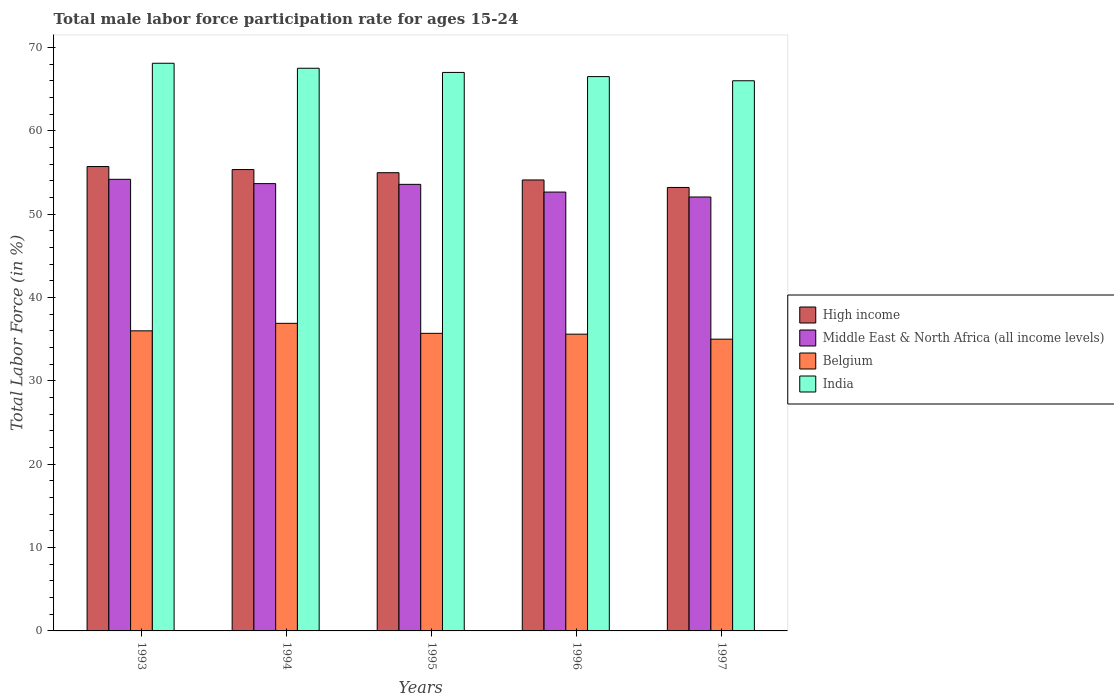How many different coloured bars are there?
Provide a succinct answer. 4. How many groups of bars are there?
Make the answer very short. 5. Are the number of bars per tick equal to the number of legend labels?
Offer a very short reply. Yes. How many bars are there on the 1st tick from the right?
Ensure brevity in your answer.  4. In how many cases, is the number of bars for a given year not equal to the number of legend labels?
Ensure brevity in your answer.  0. What is the male labor force participation rate in India in 1993?
Your answer should be compact. 68.1. Across all years, what is the maximum male labor force participation rate in India?
Keep it short and to the point. 68.1. Across all years, what is the minimum male labor force participation rate in High income?
Keep it short and to the point. 53.2. In which year was the male labor force participation rate in High income maximum?
Offer a very short reply. 1993. In which year was the male labor force participation rate in High income minimum?
Make the answer very short. 1997. What is the total male labor force participation rate in India in the graph?
Keep it short and to the point. 335.1. What is the difference between the male labor force participation rate in Middle East & North Africa (all income levels) in 1993 and that in 1996?
Give a very brief answer. 1.53. What is the difference between the male labor force participation rate in India in 1994 and the male labor force participation rate in Belgium in 1995?
Give a very brief answer. 31.8. What is the average male labor force participation rate in High income per year?
Keep it short and to the point. 54.67. In the year 1993, what is the difference between the male labor force participation rate in Belgium and male labor force participation rate in High income?
Your answer should be very brief. -19.71. What is the ratio of the male labor force participation rate in Middle East & North Africa (all income levels) in 1993 to that in 1995?
Ensure brevity in your answer.  1.01. Is the male labor force participation rate in High income in 1995 less than that in 1996?
Provide a short and direct response. No. Is the difference between the male labor force participation rate in Belgium in 1994 and 1996 greater than the difference between the male labor force participation rate in High income in 1994 and 1996?
Your answer should be very brief. Yes. What is the difference between the highest and the second highest male labor force participation rate in Belgium?
Keep it short and to the point. 0.9. What is the difference between the highest and the lowest male labor force participation rate in India?
Your answer should be very brief. 2.1. Is the sum of the male labor force participation rate in High income in 1994 and 1996 greater than the maximum male labor force participation rate in Middle East & North Africa (all income levels) across all years?
Keep it short and to the point. Yes. What does the 2nd bar from the left in 1995 represents?
Your answer should be very brief. Middle East & North Africa (all income levels). What does the 4th bar from the right in 1995 represents?
Ensure brevity in your answer.  High income. Is it the case that in every year, the sum of the male labor force participation rate in Middle East & North Africa (all income levels) and male labor force participation rate in India is greater than the male labor force participation rate in Belgium?
Make the answer very short. Yes. How many years are there in the graph?
Provide a short and direct response. 5. What is the difference between two consecutive major ticks on the Y-axis?
Your response must be concise. 10. Are the values on the major ticks of Y-axis written in scientific E-notation?
Ensure brevity in your answer.  No. Does the graph contain any zero values?
Give a very brief answer. No. Where does the legend appear in the graph?
Your answer should be very brief. Center right. How many legend labels are there?
Provide a succinct answer. 4. How are the legend labels stacked?
Your answer should be very brief. Vertical. What is the title of the graph?
Your answer should be compact. Total male labor force participation rate for ages 15-24. What is the label or title of the X-axis?
Your response must be concise. Years. What is the Total Labor Force (in %) of High income in 1993?
Offer a very short reply. 55.71. What is the Total Labor Force (in %) of Middle East & North Africa (all income levels) in 1993?
Your answer should be compact. 54.18. What is the Total Labor Force (in %) of India in 1993?
Provide a succinct answer. 68.1. What is the Total Labor Force (in %) in High income in 1994?
Your answer should be compact. 55.35. What is the Total Labor Force (in %) of Middle East & North Africa (all income levels) in 1994?
Make the answer very short. 53.66. What is the Total Labor Force (in %) in Belgium in 1994?
Make the answer very short. 36.9. What is the Total Labor Force (in %) of India in 1994?
Provide a short and direct response. 67.5. What is the Total Labor Force (in %) of High income in 1995?
Provide a succinct answer. 54.97. What is the Total Labor Force (in %) in Middle East & North Africa (all income levels) in 1995?
Keep it short and to the point. 53.57. What is the Total Labor Force (in %) of Belgium in 1995?
Provide a succinct answer. 35.7. What is the Total Labor Force (in %) of High income in 1996?
Keep it short and to the point. 54.1. What is the Total Labor Force (in %) in Middle East & North Africa (all income levels) in 1996?
Make the answer very short. 52.65. What is the Total Labor Force (in %) of Belgium in 1996?
Give a very brief answer. 35.6. What is the Total Labor Force (in %) of India in 1996?
Offer a very short reply. 66.5. What is the Total Labor Force (in %) of High income in 1997?
Make the answer very short. 53.2. What is the Total Labor Force (in %) in Middle East & North Africa (all income levels) in 1997?
Make the answer very short. 52.06. What is the Total Labor Force (in %) of Belgium in 1997?
Your answer should be compact. 35. What is the Total Labor Force (in %) of India in 1997?
Give a very brief answer. 66. Across all years, what is the maximum Total Labor Force (in %) of High income?
Offer a very short reply. 55.71. Across all years, what is the maximum Total Labor Force (in %) in Middle East & North Africa (all income levels)?
Ensure brevity in your answer.  54.18. Across all years, what is the maximum Total Labor Force (in %) of Belgium?
Give a very brief answer. 36.9. Across all years, what is the maximum Total Labor Force (in %) of India?
Ensure brevity in your answer.  68.1. Across all years, what is the minimum Total Labor Force (in %) of High income?
Your response must be concise. 53.2. Across all years, what is the minimum Total Labor Force (in %) of Middle East & North Africa (all income levels)?
Your answer should be very brief. 52.06. What is the total Total Labor Force (in %) in High income in the graph?
Keep it short and to the point. 273.33. What is the total Total Labor Force (in %) in Middle East & North Africa (all income levels) in the graph?
Give a very brief answer. 266.12. What is the total Total Labor Force (in %) of Belgium in the graph?
Your answer should be very brief. 179.2. What is the total Total Labor Force (in %) of India in the graph?
Offer a terse response. 335.1. What is the difference between the Total Labor Force (in %) in High income in 1993 and that in 1994?
Your response must be concise. 0.36. What is the difference between the Total Labor Force (in %) in Middle East & North Africa (all income levels) in 1993 and that in 1994?
Provide a short and direct response. 0.52. What is the difference between the Total Labor Force (in %) of Belgium in 1993 and that in 1994?
Keep it short and to the point. -0.9. What is the difference between the Total Labor Force (in %) of High income in 1993 and that in 1995?
Your answer should be very brief. 0.74. What is the difference between the Total Labor Force (in %) in Middle East & North Africa (all income levels) in 1993 and that in 1995?
Make the answer very short. 0.61. What is the difference between the Total Labor Force (in %) in Belgium in 1993 and that in 1995?
Your answer should be very brief. 0.3. What is the difference between the Total Labor Force (in %) in High income in 1993 and that in 1996?
Provide a short and direct response. 1.61. What is the difference between the Total Labor Force (in %) of Middle East & North Africa (all income levels) in 1993 and that in 1996?
Provide a short and direct response. 1.53. What is the difference between the Total Labor Force (in %) of High income in 1993 and that in 1997?
Your answer should be very brief. 2.51. What is the difference between the Total Labor Force (in %) of Middle East & North Africa (all income levels) in 1993 and that in 1997?
Keep it short and to the point. 2.12. What is the difference between the Total Labor Force (in %) in India in 1993 and that in 1997?
Provide a succinct answer. 2.1. What is the difference between the Total Labor Force (in %) in High income in 1994 and that in 1995?
Give a very brief answer. 0.38. What is the difference between the Total Labor Force (in %) of Middle East & North Africa (all income levels) in 1994 and that in 1995?
Your answer should be very brief. 0.09. What is the difference between the Total Labor Force (in %) of Belgium in 1994 and that in 1995?
Offer a terse response. 1.2. What is the difference between the Total Labor Force (in %) of India in 1994 and that in 1995?
Offer a very short reply. 0.5. What is the difference between the Total Labor Force (in %) in High income in 1994 and that in 1996?
Provide a succinct answer. 1.25. What is the difference between the Total Labor Force (in %) of Middle East & North Africa (all income levels) in 1994 and that in 1996?
Your answer should be very brief. 1.01. What is the difference between the Total Labor Force (in %) of Belgium in 1994 and that in 1996?
Offer a very short reply. 1.3. What is the difference between the Total Labor Force (in %) of India in 1994 and that in 1996?
Give a very brief answer. 1. What is the difference between the Total Labor Force (in %) of High income in 1994 and that in 1997?
Provide a short and direct response. 2.15. What is the difference between the Total Labor Force (in %) in Middle East & North Africa (all income levels) in 1994 and that in 1997?
Offer a terse response. 1.61. What is the difference between the Total Labor Force (in %) of Belgium in 1994 and that in 1997?
Offer a terse response. 1.9. What is the difference between the Total Labor Force (in %) of India in 1994 and that in 1997?
Offer a terse response. 1.5. What is the difference between the Total Labor Force (in %) in High income in 1995 and that in 1996?
Make the answer very short. 0.87. What is the difference between the Total Labor Force (in %) in Middle East & North Africa (all income levels) in 1995 and that in 1996?
Provide a short and direct response. 0.93. What is the difference between the Total Labor Force (in %) in India in 1995 and that in 1996?
Provide a succinct answer. 0.5. What is the difference between the Total Labor Force (in %) of High income in 1995 and that in 1997?
Provide a short and direct response. 1.77. What is the difference between the Total Labor Force (in %) in Middle East & North Africa (all income levels) in 1995 and that in 1997?
Give a very brief answer. 1.52. What is the difference between the Total Labor Force (in %) in Belgium in 1995 and that in 1997?
Offer a terse response. 0.7. What is the difference between the Total Labor Force (in %) in India in 1995 and that in 1997?
Ensure brevity in your answer.  1. What is the difference between the Total Labor Force (in %) in High income in 1996 and that in 1997?
Give a very brief answer. 0.9. What is the difference between the Total Labor Force (in %) in Middle East & North Africa (all income levels) in 1996 and that in 1997?
Provide a succinct answer. 0.59. What is the difference between the Total Labor Force (in %) in Belgium in 1996 and that in 1997?
Make the answer very short. 0.6. What is the difference between the Total Labor Force (in %) of High income in 1993 and the Total Labor Force (in %) of Middle East & North Africa (all income levels) in 1994?
Provide a short and direct response. 2.05. What is the difference between the Total Labor Force (in %) in High income in 1993 and the Total Labor Force (in %) in Belgium in 1994?
Your answer should be very brief. 18.81. What is the difference between the Total Labor Force (in %) of High income in 1993 and the Total Labor Force (in %) of India in 1994?
Your answer should be very brief. -11.79. What is the difference between the Total Labor Force (in %) of Middle East & North Africa (all income levels) in 1993 and the Total Labor Force (in %) of Belgium in 1994?
Keep it short and to the point. 17.28. What is the difference between the Total Labor Force (in %) in Middle East & North Africa (all income levels) in 1993 and the Total Labor Force (in %) in India in 1994?
Your response must be concise. -13.32. What is the difference between the Total Labor Force (in %) of Belgium in 1993 and the Total Labor Force (in %) of India in 1994?
Give a very brief answer. -31.5. What is the difference between the Total Labor Force (in %) in High income in 1993 and the Total Labor Force (in %) in Middle East & North Africa (all income levels) in 1995?
Your response must be concise. 2.14. What is the difference between the Total Labor Force (in %) of High income in 1993 and the Total Labor Force (in %) of Belgium in 1995?
Provide a short and direct response. 20.01. What is the difference between the Total Labor Force (in %) in High income in 1993 and the Total Labor Force (in %) in India in 1995?
Give a very brief answer. -11.29. What is the difference between the Total Labor Force (in %) of Middle East & North Africa (all income levels) in 1993 and the Total Labor Force (in %) of Belgium in 1995?
Provide a succinct answer. 18.48. What is the difference between the Total Labor Force (in %) of Middle East & North Africa (all income levels) in 1993 and the Total Labor Force (in %) of India in 1995?
Ensure brevity in your answer.  -12.82. What is the difference between the Total Labor Force (in %) in Belgium in 1993 and the Total Labor Force (in %) in India in 1995?
Provide a succinct answer. -31. What is the difference between the Total Labor Force (in %) of High income in 1993 and the Total Labor Force (in %) of Middle East & North Africa (all income levels) in 1996?
Provide a short and direct response. 3.06. What is the difference between the Total Labor Force (in %) in High income in 1993 and the Total Labor Force (in %) in Belgium in 1996?
Your response must be concise. 20.11. What is the difference between the Total Labor Force (in %) of High income in 1993 and the Total Labor Force (in %) of India in 1996?
Give a very brief answer. -10.79. What is the difference between the Total Labor Force (in %) in Middle East & North Africa (all income levels) in 1993 and the Total Labor Force (in %) in Belgium in 1996?
Make the answer very short. 18.58. What is the difference between the Total Labor Force (in %) of Middle East & North Africa (all income levels) in 1993 and the Total Labor Force (in %) of India in 1996?
Your answer should be compact. -12.32. What is the difference between the Total Labor Force (in %) of Belgium in 1993 and the Total Labor Force (in %) of India in 1996?
Your answer should be very brief. -30.5. What is the difference between the Total Labor Force (in %) of High income in 1993 and the Total Labor Force (in %) of Middle East & North Africa (all income levels) in 1997?
Your response must be concise. 3.65. What is the difference between the Total Labor Force (in %) in High income in 1993 and the Total Labor Force (in %) in Belgium in 1997?
Your answer should be very brief. 20.71. What is the difference between the Total Labor Force (in %) of High income in 1993 and the Total Labor Force (in %) of India in 1997?
Provide a succinct answer. -10.29. What is the difference between the Total Labor Force (in %) in Middle East & North Africa (all income levels) in 1993 and the Total Labor Force (in %) in Belgium in 1997?
Your answer should be very brief. 19.18. What is the difference between the Total Labor Force (in %) of Middle East & North Africa (all income levels) in 1993 and the Total Labor Force (in %) of India in 1997?
Give a very brief answer. -11.82. What is the difference between the Total Labor Force (in %) in Belgium in 1993 and the Total Labor Force (in %) in India in 1997?
Give a very brief answer. -30. What is the difference between the Total Labor Force (in %) in High income in 1994 and the Total Labor Force (in %) in Middle East & North Africa (all income levels) in 1995?
Provide a succinct answer. 1.78. What is the difference between the Total Labor Force (in %) of High income in 1994 and the Total Labor Force (in %) of Belgium in 1995?
Provide a short and direct response. 19.65. What is the difference between the Total Labor Force (in %) of High income in 1994 and the Total Labor Force (in %) of India in 1995?
Provide a succinct answer. -11.65. What is the difference between the Total Labor Force (in %) in Middle East & North Africa (all income levels) in 1994 and the Total Labor Force (in %) in Belgium in 1995?
Your answer should be compact. 17.96. What is the difference between the Total Labor Force (in %) of Middle East & North Africa (all income levels) in 1994 and the Total Labor Force (in %) of India in 1995?
Ensure brevity in your answer.  -13.34. What is the difference between the Total Labor Force (in %) of Belgium in 1994 and the Total Labor Force (in %) of India in 1995?
Give a very brief answer. -30.1. What is the difference between the Total Labor Force (in %) in High income in 1994 and the Total Labor Force (in %) in Middle East & North Africa (all income levels) in 1996?
Your answer should be compact. 2.7. What is the difference between the Total Labor Force (in %) of High income in 1994 and the Total Labor Force (in %) of Belgium in 1996?
Your answer should be compact. 19.75. What is the difference between the Total Labor Force (in %) in High income in 1994 and the Total Labor Force (in %) in India in 1996?
Your answer should be compact. -11.15. What is the difference between the Total Labor Force (in %) of Middle East & North Africa (all income levels) in 1994 and the Total Labor Force (in %) of Belgium in 1996?
Ensure brevity in your answer.  18.06. What is the difference between the Total Labor Force (in %) of Middle East & North Africa (all income levels) in 1994 and the Total Labor Force (in %) of India in 1996?
Make the answer very short. -12.84. What is the difference between the Total Labor Force (in %) of Belgium in 1994 and the Total Labor Force (in %) of India in 1996?
Your answer should be very brief. -29.6. What is the difference between the Total Labor Force (in %) of High income in 1994 and the Total Labor Force (in %) of Middle East & North Africa (all income levels) in 1997?
Provide a short and direct response. 3.29. What is the difference between the Total Labor Force (in %) in High income in 1994 and the Total Labor Force (in %) in Belgium in 1997?
Your response must be concise. 20.35. What is the difference between the Total Labor Force (in %) of High income in 1994 and the Total Labor Force (in %) of India in 1997?
Provide a succinct answer. -10.65. What is the difference between the Total Labor Force (in %) of Middle East & North Africa (all income levels) in 1994 and the Total Labor Force (in %) of Belgium in 1997?
Your answer should be very brief. 18.66. What is the difference between the Total Labor Force (in %) of Middle East & North Africa (all income levels) in 1994 and the Total Labor Force (in %) of India in 1997?
Offer a terse response. -12.34. What is the difference between the Total Labor Force (in %) in Belgium in 1994 and the Total Labor Force (in %) in India in 1997?
Provide a short and direct response. -29.1. What is the difference between the Total Labor Force (in %) of High income in 1995 and the Total Labor Force (in %) of Middle East & North Africa (all income levels) in 1996?
Offer a terse response. 2.32. What is the difference between the Total Labor Force (in %) of High income in 1995 and the Total Labor Force (in %) of Belgium in 1996?
Make the answer very short. 19.37. What is the difference between the Total Labor Force (in %) of High income in 1995 and the Total Labor Force (in %) of India in 1996?
Provide a short and direct response. -11.53. What is the difference between the Total Labor Force (in %) of Middle East & North Africa (all income levels) in 1995 and the Total Labor Force (in %) of Belgium in 1996?
Provide a succinct answer. 17.97. What is the difference between the Total Labor Force (in %) in Middle East & North Africa (all income levels) in 1995 and the Total Labor Force (in %) in India in 1996?
Offer a terse response. -12.93. What is the difference between the Total Labor Force (in %) in Belgium in 1995 and the Total Labor Force (in %) in India in 1996?
Provide a succinct answer. -30.8. What is the difference between the Total Labor Force (in %) in High income in 1995 and the Total Labor Force (in %) in Middle East & North Africa (all income levels) in 1997?
Give a very brief answer. 2.91. What is the difference between the Total Labor Force (in %) of High income in 1995 and the Total Labor Force (in %) of Belgium in 1997?
Provide a short and direct response. 19.97. What is the difference between the Total Labor Force (in %) in High income in 1995 and the Total Labor Force (in %) in India in 1997?
Offer a terse response. -11.03. What is the difference between the Total Labor Force (in %) in Middle East & North Africa (all income levels) in 1995 and the Total Labor Force (in %) in Belgium in 1997?
Offer a terse response. 18.57. What is the difference between the Total Labor Force (in %) of Middle East & North Africa (all income levels) in 1995 and the Total Labor Force (in %) of India in 1997?
Your answer should be compact. -12.43. What is the difference between the Total Labor Force (in %) in Belgium in 1995 and the Total Labor Force (in %) in India in 1997?
Your answer should be compact. -30.3. What is the difference between the Total Labor Force (in %) of High income in 1996 and the Total Labor Force (in %) of Middle East & North Africa (all income levels) in 1997?
Keep it short and to the point. 2.04. What is the difference between the Total Labor Force (in %) in High income in 1996 and the Total Labor Force (in %) in Belgium in 1997?
Give a very brief answer. 19.1. What is the difference between the Total Labor Force (in %) of High income in 1996 and the Total Labor Force (in %) of India in 1997?
Give a very brief answer. -11.9. What is the difference between the Total Labor Force (in %) in Middle East & North Africa (all income levels) in 1996 and the Total Labor Force (in %) in Belgium in 1997?
Offer a very short reply. 17.65. What is the difference between the Total Labor Force (in %) in Middle East & North Africa (all income levels) in 1996 and the Total Labor Force (in %) in India in 1997?
Provide a short and direct response. -13.35. What is the difference between the Total Labor Force (in %) in Belgium in 1996 and the Total Labor Force (in %) in India in 1997?
Your response must be concise. -30.4. What is the average Total Labor Force (in %) of High income per year?
Ensure brevity in your answer.  54.67. What is the average Total Labor Force (in %) in Middle East & North Africa (all income levels) per year?
Keep it short and to the point. 53.22. What is the average Total Labor Force (in %) in Belgium per year?
Give a very brief answer. 35.84. What is the average Total Labor Force (in %) of India per year?
Your answer should be compact. 67.02. In the year 1993, what is the difference between the Total Labor Force (in %) in High income and Total Labor Force (in %) in Middle East & North Africa (all income levels)?
Ensure brevity in your answer.  1.53. In the year 1993, what is the difference between the Total Labor Force (in %) of High income and Total Labor Force (in %) of Belgium?
Your answer should be very brief. 19.71. In the year 1993, what is the difference between the Total Labor Force (in %) in High income and Total Labor Force (in %) in India?
Offer a very short reply. -12.39. In the year 1993, what is the difference between the Total Labor Force (in %) of Middle East & North Africa (all income levels) and Total Labor Force (in %) of Belgium?
Offer a very short reply. 18.18. In the year 1993, what is the difference between the Total Labor Force (in %) of Middle East & North Africa (all income levels) and Total Labor Force (in %) of India?
Give a very brief answer. -13.92. In the year 1993, what is the difference between the Total Labor Force (in %) of Belgium and Total Labor Force (in %) of India?
Keep it short and to the point. -32.1. In the year 1994, what is the difference between the Total Labor Force (in %) in High income and Total Labor Force (in %) in Middle East & North Africa (all income levels)?
Offer a very short reply. 1.69. In the year 1994, what is the difference between the Total Labor Force (in %) in High income and Total Labor Force (in %) in Belgium?
Ensure brevity in your answer.  18.45. In the year 1994, what is the difference between the Total Labor Force (in %) in High income and Total Labor Force (in %) in India?
Your answer should be very brief. -12.15. In the year 1994, what is the difference between the Total Labor Force (in %) of Middle East & North Africa (all income levels) and Total Labor Force (in %) of Belgium?
Provide a short and direct response. 16.76. In the year 1994, what is the difference between the Total Labor Force (in %) in Middle East & North Africa (all income levels) and Total Labor Force (in %) in India?
Ensure brevity in your answer.  -13.84. In the year 1994, what is the difference between the Total Labor Force (in %) of Belgium and Total Labor Force (in %) of India?
Offer a terse response. -30.6. In the year 1995, what is the difference between the Total Labor Force (in %) of High income and Total Labor Force (in %) of Middle East & North Africa (all income levels)?
Provide a succinct answer. 1.4. In the year 1995, what is the difference between the Total Labor Force (in %) in High income and Total Labor Force (in %) in Belgium?
Make the answer very short. 19.27. In the year 1995, what is the difference between the Total Labor Force (in %) of High income and Total Labor Force (in %) of India?
Your response must be concise. -12.03. In the year 1995, what is the difference between the Total Labor Force (in %) of Middle East & North Africa (all income levels) and Total Labor Force (in %) of Belgium?
Provide a succinct answer. 17.87. In the year 1995, what is the difference between the Total Labor Force (in %) in Middle East & North Africa (all income levels) and Total Labor Force (in %) in India?
Keep it short and to the point. -13.43. In the year 1995, what is the difference between the Total Labor Force (in %) of Belgium and Total Labor Force (in %) of India?
Keep it short and to the point. -31.3. In the year 1996, what is the difference between the Total Labor Force (in %) in High income and Total Labor Force (in %) in Middle East & North Africa (all income levels)?
Offer a terse response. 1.45. In the year 1996, what is the difference between the Total Labor Force (in %) of High income and Total Labor Force (in %) of Belgium?
Your answer should be very brief. 18.5. In the year 1996, what is the difference between the Total Labor Force (in %) of High income and Total Labor Force (in %) of India?
Make the answer very short. -12.4. In the year 1996, what is the difference between the Total Labor Force (in %) in Middle East & North Africa (all income levels) and Total Labor Force (in %) in Belgium?
Your answer should be very brief. 17.05. In the year 1996, what is the difference between the Total Labor Force (in %) of Middle East & North Africa (all income levels) and Total Labor Force (in %) of India?
Your answer should be compact. -13.85. In the year 1996, what is the difference between the Total Labor Force (in %) in Belgium and Total Labor Force (in %) in India?
Ensure brevity in your answer.  -30.9. In the year 1997, what is the difference between the Total Labor Force (in %) in High income and Total Labor Force (in %) in Middle East & North Africa (all income levels)?
Offer a terse response. 1.14. In the year 1997, what is the difference between the Total Labor Force (in %) in High income and Total Labor Force (in %) in Belgium?
Give a very brief answer. 18.2. In the year 1997, what is the difference between the Total Labor Force (in %) of High income and Total Labor Force (in %) of India?
Keep it short and to the point. -12.8. In the year 1997, what is the difference between the Total Labor Force (in %) of Middle East & North Africa (all income levels) and Total Labor Force (in %) of Belgium?
Your answer should be very brief. 17.06. In the year 1997, what is the difference between the Total Labor Force (in %) in Middle East & North Africa (all income levels) and Total Labor Force (in %) in India?
Keep it short and to the point. -13.94. In the year 1997, what is the difference between the Total Labor Force (in %) in Belgium and Total Labor Force (in %) in India?
Keep it short and to the point. -31. What is the ratio of the Total Labor Force (in %) in High income in 1993 to that in 1994?
Provide a succinct answer. 1.01. What is the ratio of the Total Labor Force (in %) of Middle East & North Africa (all income levels) in 1993 to that in 1994?
Provide a short and direct response. 1.01. What is the ratio of the Total Labor Force (in %) of Belgium in 1993 to that in 1994?
Your response must be concise. 0.98. What is the ratio of the Total Labor Force (in %) of India in 1993 to that in 1994?
Provide a short and direct response. 1.01. What is the ratio of the Total Labor Force (in %) in High income in 1993 to that in 1995?
Offer a very short reply. 1.01. What is the ratio of the Total Labor Force (in %) of Middle East & North Africa (all income levels) in 1993 to that in 1995?
Your response must be concise. 1.01. What is the ratio of the Total Labor Force (in %) in Belgium in 1993 to that in 1995?
Your response must be concise. 1.01. What is the ratio of the Total Labor Force (in %) of India in 1993 to that in 1995?
Your answer should be very brief. 1.02. What is the ratio of the Total Labor Force (in %) in High income in 1993 to that in 1996?
Your response must be concise. 1.03. What is the ratio of the Total Labor Force (in %) in Middle East & North Africa (all income levels) in 1993 to that in 1996?
Offer a very short reply. 1.03. What is the ratio of the Total Labor Force (in %) of Belgium in 1993 to that in 1996?
Your response must be concise. 1.01. What is the ratio of the Total Labor Force (in %) of India in 1993 to that in 1996?
Your response must be concise. 1.02. What is the ratio of the Total Labor Force (in %) in High income in 1993 to that in 1997?
Provide a short and direct response. 1.05. What is the ratio of the Total Labor Force (in %) in Middle East & North Africa (all income levels) in 1993 to that in 1997?
Offer a very short reply. 1.04. What is the ratio of the Total Labor Force (in %) of Belgium in 1993 to that in 1997?
Keep it short and to the point. 1.03. What is the ratio of the Total Labor Force (in %) of India in 1993 to that in 1997?
Your answer should be compact. 1.03. What is the ratio of the Total Labor Force (in %) in Belgium in 1994 to that in 1995?
Provide a short and direct response. 1.03. What is the ratio of the Total Labor Force (in %) of India in 1994 to that in 1995?
Provide a short and direct response. 1.01. What is the ratio of the Total Labor Force (in %) in High income in 1994 to that in 1996?
Give a very brief answer. 1.02. What is the ratio of the Total Labor Force (in %) of Middle East & North Africa (all income levels) in 1994 to that in 1996?
Offer a very short reply. 1.02. What is the ratio of the Total Labor Force (in %) of Belgium in 1994 to that in 1996?
Give a very brief answer. 1.04. What is the ratio of the Total Labor Force (in %) in High income in 1994 to that in 1997?
Your answer should be very brief. 1.04. What is the ratio of the Total Labor Force (in %) of Middle East & North Africa (all income levels) in 1994 to that in 1997?
Provide a succinct answer. 1.03. What is the ratio of the Total Labor Force (in %) in Belgium in 1994 to that in 1997?
Give a very brief answer. 1.05. What is the ratio of the Total Labor Force (in %) in India in 1994 to that in 1997?
Your answer should be very brief. 1.02. What is the ratio of the Total Labor Force (in %) of High income in 1995 to that in 1996?
Provide a succinct answer. 1.02. What is the ratio of the Total Labor Force (in %) of Middle East & North Africa (all income levels) in 1995 to that in 1996?
Your answer should be very brief. 1.02. What is the ratio of the Total Labor Force (in %) in India in 1995 to that in 1996?
Your response must be concise. 1.01. What is the ratio of the Total Labor Force (in %) of Middle East & North Africa (all income levels) in 1995 to that in 1997?
Provide a short and direct response. 1.03. What is the ratio of the Total Labor Force (in %) of India in 1995 to that in 1997?
Offer a very short reply. 1.02. What is the ratio of the Total Labor Force (in %) of High income in 1996 to that in 1997?
Offer a terse response. 1.02. What is the ratio of the Total Labor Force (in %) of Middle East & North Africa (all income levels) in 1996 to that in 1997?
Your answer should be compact. 1.01. What is the ratio of the Total Labor Force (in %) of Belgium in 1996 to that in 1997?
Offer a terse response. 1.02. What is the ratio of the Total Labor Force (in %) of India in 1996 to that in 1997?
Give a very brief answer. 1.01. What is the difference between the highest and the second highest Total Labor Force (in %) in High income?
Your answer should be compact. 0.36. What is the difference between the highest and the second highest Total Labor Force (in %) of Middle East & North Africa (all income levels)?
Your response must be concise. 0.52. What is the difference between the highest and the second highest Total Labor Force (in %) in India?
Your answer should be compact. 0.6. What is the difference between the highest and the lowest Total Labor Force (in %) of High income?
Your response must be concise. 2.51. What is the difference between the highest and the lowest Total Labor Force (in %) of Middle East & North Africa (all income levels)?
Your answer should be compact. 2.12. What is the difference between the highest and the lowest Total Labor Force (in %) of Belgium?
Give a very brief answer. 1.9. 